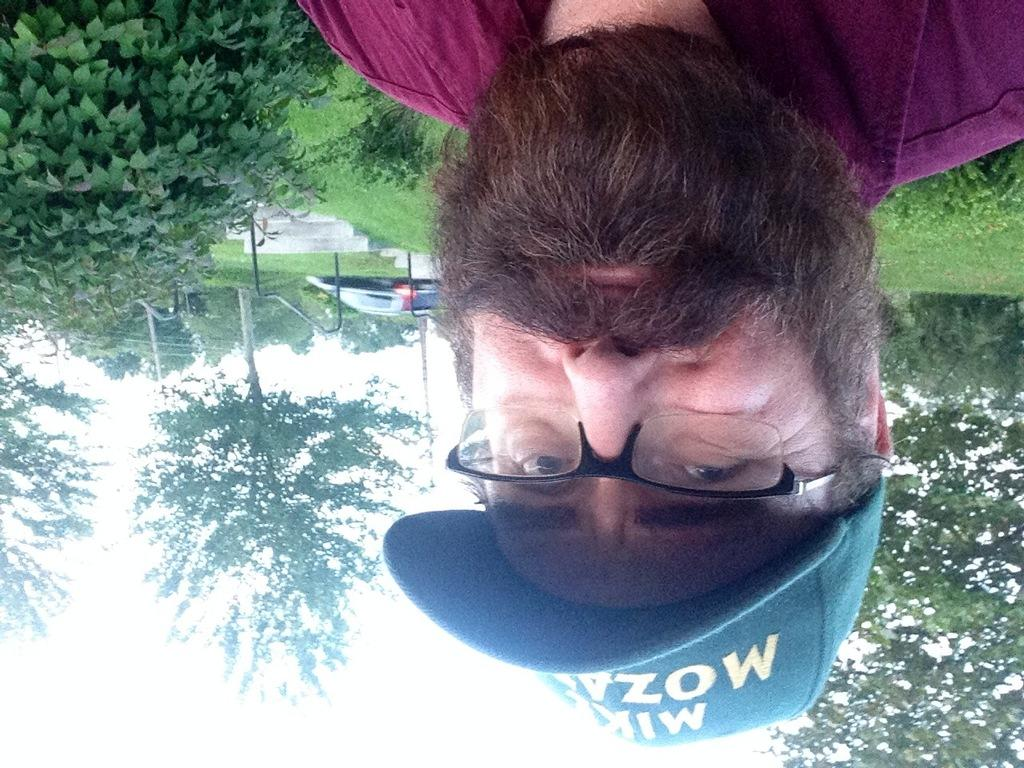Who is in the image? There is a person in the image. Can you describe the person's appearance? The person has a beard, is wearing spectacles, and has a cap on. What is the background of the image like? The ground behind the person is greenery, and there are trees in the background. What type of pear is being cooked on the stove in the image? There is no pear or stove present in the image. What kind of machine is being used by the person in the image? There is no machine visible in the image; the person is not using any tools or equipment. 